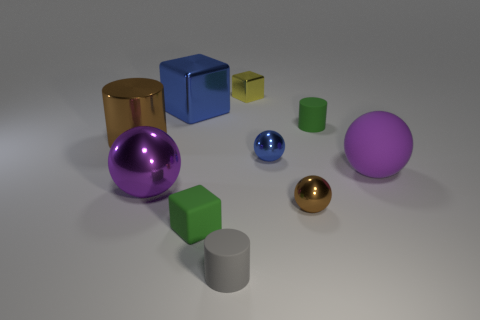Subtract all balls. How many objects are left? 6 Add 2 gray cylinders. How many gray cylinders exist? 3 Subtract 1 purple balls. How many objects are left? 9 Subtract all small green matte things. Subtract all small green blocks. How many objects are left? 7 Add 8 green matte blocks. How many green matte blocks are left? 9 